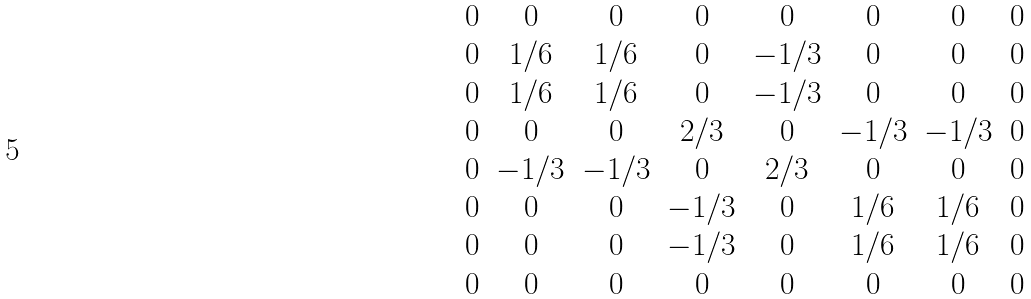<formula> <loc_0><loc_0><loc_500><loc_500>\begin{matrix} 0 & 0 & 0 & 0 & 0 & 0 & 0 & 0 \\ 0 & 1 / 6 & 1 / 6 & 0 & - 1 / 3 & 0 & 0 & 0 \\ 0 & 1 / 6 & 1 / 6 & 0 & - 1 / 3 & 0 & 0 & 0 \\ 0 & 0 & 0 & 2 / 3 & 0 & - 1 / 3 & - 1 / 3 & 0 \\ 0 & - 1 / 3 & - 1 / 3 & 0 & 2 / 3 & 0 & 0 & 0 \\ 0 & 0 & 0 & - 1 / 3 & 0 & 1 / 6 & 1 / 6 & 0 \\ 0 & 0 & 0 & - 1 / 3 & 0 & 1 / 6 & 1 / 6 & 0 \\ 0 & 0 & 0 & 0 & 0 & 0 & 0 & 0 \end{matrix}</formula> 